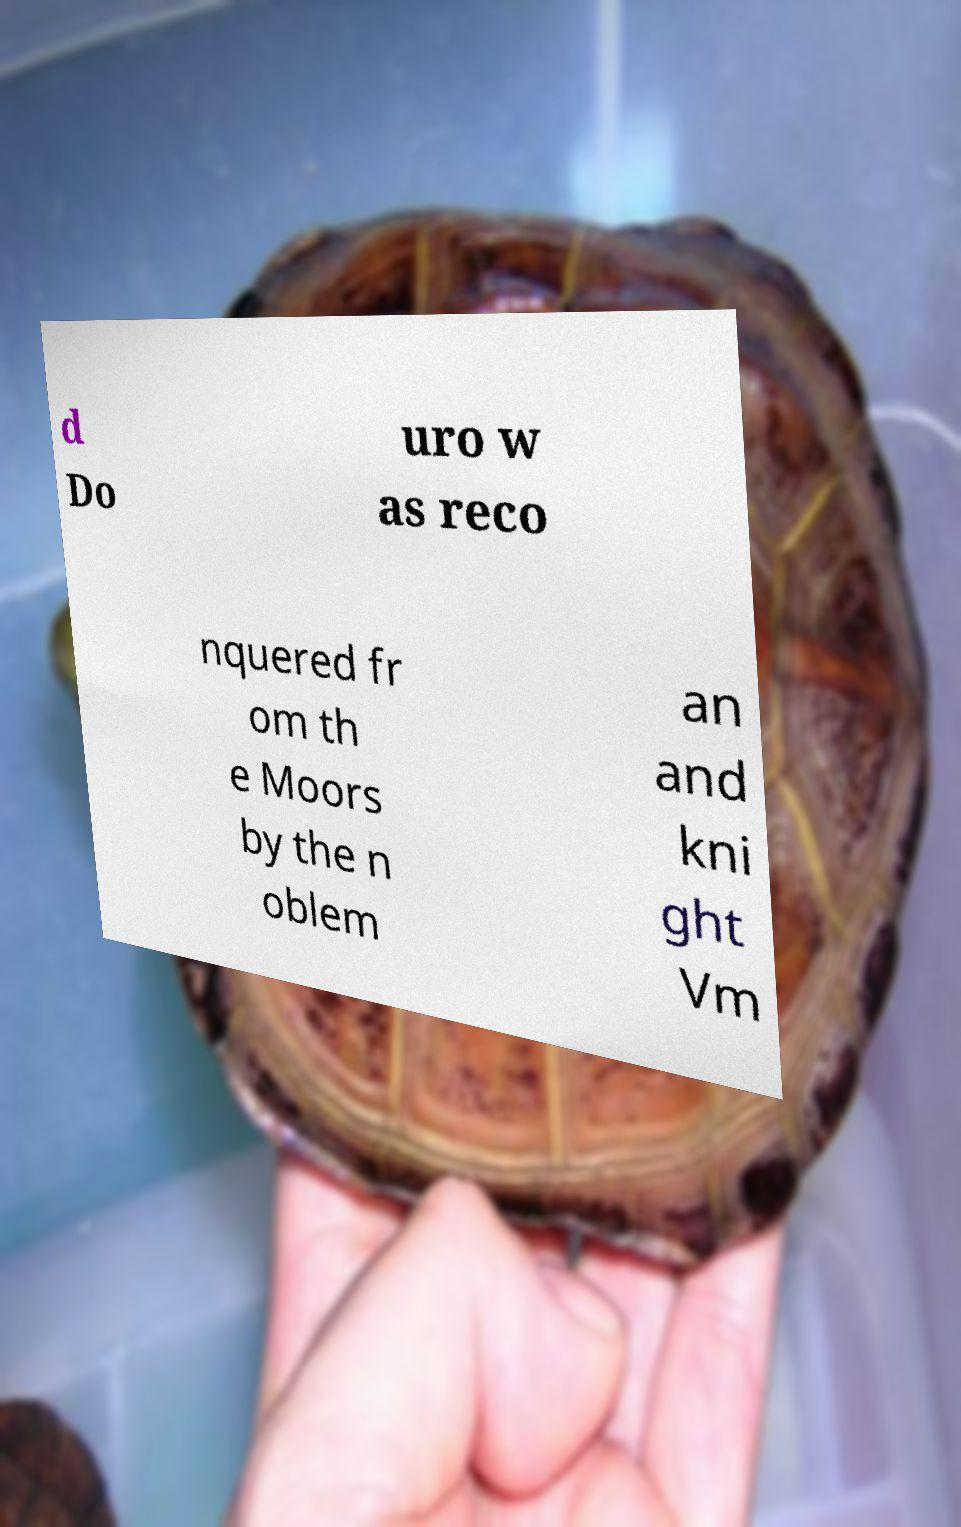Please identify and transcribe the text found in this image. d Do uro w as reco nquered fr om th e Moors by the n oblem an and kni ght Vm 